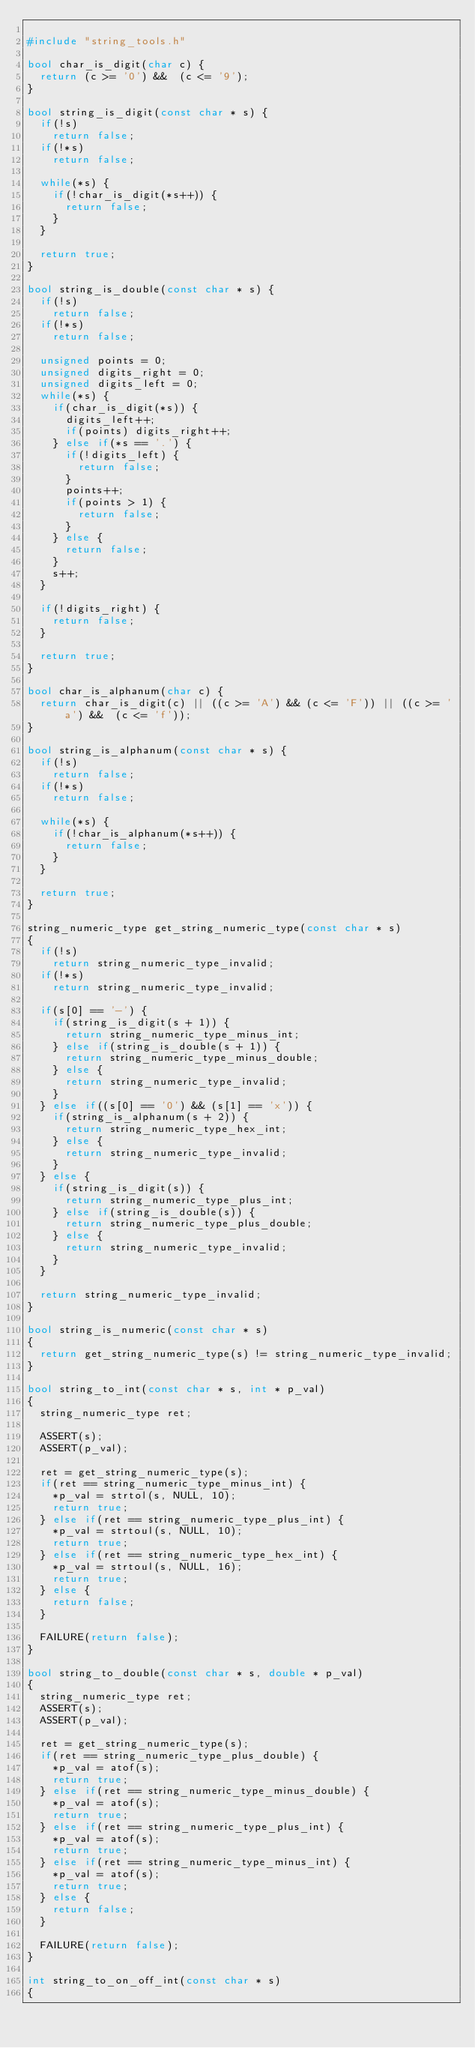<code> <loc_0><loc_0><loc_500><loc_500><_C++_>
#include "string_tools.h"

bool char_is_digit(char c) {
  return (c >= '0') &&  (c <= '9');
}

bool string_is_digit(const char * s) {
  if(!s)
    return false;
  if(!*s)
    return false;

  while(*s) {
    if(!char_is_digit(*s++)) {
      return false;
    }
  }

  return true;
}

bool string_is_double(const char * s) {
  if(!s)
    return false;
  if(!*s)
    return false;

  unsigned points = 0;
  unsigned digits_right = 0;
  unsigned digits_left = 0;
  while(*s) {
    if(char_is_digit(*s)) {
      digits_left++;
      if(points) digits_right++;
    } else if(*s == '.') {
      if(!digits_left) {
        return false;
      }
      points++;
      if(points > 1) {
        return false;
      }
    } else {
      return false;
    }
    s++;
  }

  if(!digits_right) {
    return false;
  }

  return true;
}

bool char_is_alphanum(char c) {
  return char_is_digit(c) || ((c >= 'A') && (c <= 'F')) || ((c >= 'a') &&  (c <= 'f'));
}

bool string_is_alphanum(const char * s) {
  if(!s)
    return false;
  if(!*s)
    return false;

  while(*s) {
    if(!char_is_alphanum(*s++)) {
      return false;
    }
  }

  return true;
}

string_numeric_type get_string_numeric_type(const char * s)
{
  if(!s)
    return string_numeric_type_invalid;
  if(!*s)
    return string_numeric_type_invalid;

  if(s[0] == '-') {
    if(string_is_digit(s + 1)) {
      return string_numeric_type_minus_int;
    } else if(string_is_double(s + 1)) {
      return string_numeric_type_minus_double;
    } else {
      return string_numeric_type_invalid;
    }
  } else if((s[0] == '0') && (s[1] == 'x')) {
    if(string_is_alphanum(s + 2)) {
      return string_numeric_type_hex_int;
    } else {
      return string_numeric_type_invalid;
    }
  } else {
    if(string_is_digit(s)) {
      return string_numeric_type_plus_int;
    } else if(string_is_double(s)) {
      return string_numeric_type_plus_double;
    } else {
      return string_numeric_type_invalid;
    }
  }

  return string_numeric_type_invalid;
}

bool string_is_numeric(const char * s)
{
  return get_string_numeric_type(s) != string_numeric_type_invalid;
}

bool string_to_int(const char * s, int * p_val)
{
  string_numeric_type ret;

  ASSERT(s);
  ASSERT(p_val);

  ret = get_string_numeric_type(s);
  if(ret == string_numeric_type_minus_int) {
    *p_val = strtol(s, NULL, 10);
    return true;
  } else if(ret == string_numeric_type_plus_int) {
    *p_val = strtoul(s, NULL, 10);
    return true;
  } else if(ret == string_numeric_type_hex_int) {
    *p_val = strtoul(s, NULL, 16);
    return true;
  } else {
    return false;
  }

  FAILURE(return false);
}

bool string_to_double(const char * s, double * p_val)
{
  string_numeric_type ret;
  ASSERT(s);
  ASSERT(p_val);

  ret = get_string_numeric_type(s);
  if(ret == string_numeric_type_plus_double) {
    *p_val = atof(s);
    return true;
  } else if(ret == string_numeric_type_minus_double) {
    *p_val = atof(s);
    return true;
  } else if(ret == string_numeric_type_plus_int) {
    *p_val = atof(s);
    return true;
  } else if(ret == string_numeric_type_minus_int) {
    *p_val = atof(s);
    return true;
  } else {
    return false;
  }

  FAILURE(return false);
}

int string_to_on_off_int(const char * s)
{</code> 